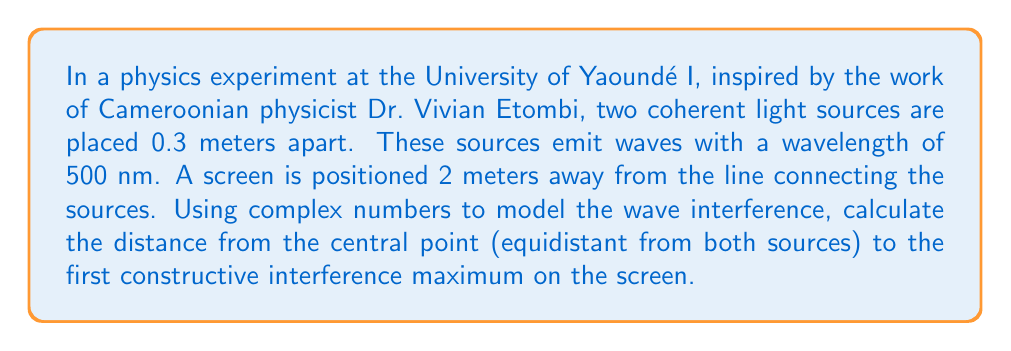Solve this math problem. To solve this problem, we'll use complex numbers to model the waves and find the point of constructive interference. Let's break it down step-by-step:

1) First, let's define our variables:
   $d$ = distance between sources = 0.3 m
   $\lambda$ = wavelength = 500 nm = $5 \times 10^{-7}$ m
   $L$ = distance to screen = 2 m
   $y$ = distance from central point to interference maximum

2) The path difference $\Delta r$ for waves to reach a point $y$ on the screen is approximately:

   $$\Delta r \approx \frac{yd}{L}$$

3) For constructive interference, this path difference should be equal to one wavelength:

   $$\frac{yd}{L} = \lambda$$

4) Now, let's use complex numbers to model the waves. At a point $y$, the two waves can be represented as:

   $$\psi_1 = A e^{i\phi_1} \quad \text{and} \quad \psi_2 = A e^{i\phi_2}$$

   where $A$ is the amplitude and $\phi$ is the phase.

5) The phase difference is related to the path difference:

   $$\phi_2 - \phi_1 = \frac{2\pi}{\lambda} \Delta r = \frac{2\pi}{\lambda} \frac{yd}{L}$$

6) For the first maximum (after the central maximum), this phase difference should be $2\pi$:

   $$\frac{2\pi}{\lambda} \frac{yd}{L} = 2\pi$$

7) Solving for $y$:

   $$y = \frac{\lambda L}{d}$$

8) Now we can substitute our values:

   $$y = \frac{(5 \times 10^{-7} \text{ m})(2 \text{ m})}{0.3 \text{ m}} = 3.33 \times 10^{-3} \text{ m}$$
Answer: The distance from the central point to the first constructive interference maximum on the screen is $3.33 \times 10^{-3}$ m or 3.33 mm. 